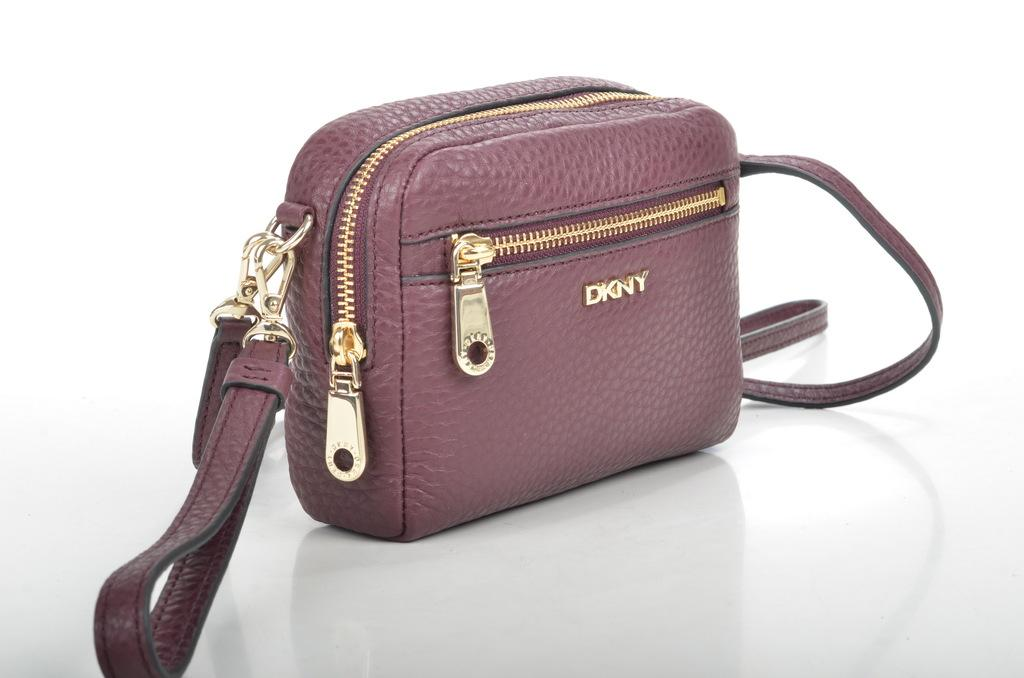What is present in the image that can hold items? There is a bag in the image that can hold items. How many zips does the bag have? The bag has 2 zips. What brand is written on the bag? "dkny" is written on the bag. Can you describe the size of the bag? It is a small bag. On what surface is the bag placed in the image? The bag is placed on a white surface. What type of throne is depicted in the image? There is no throne present in the image; it features a bag with specific details. What show is being performed on the white surface in the image? There is no show being performed in the image; it shows a bag placed on a white surface. 